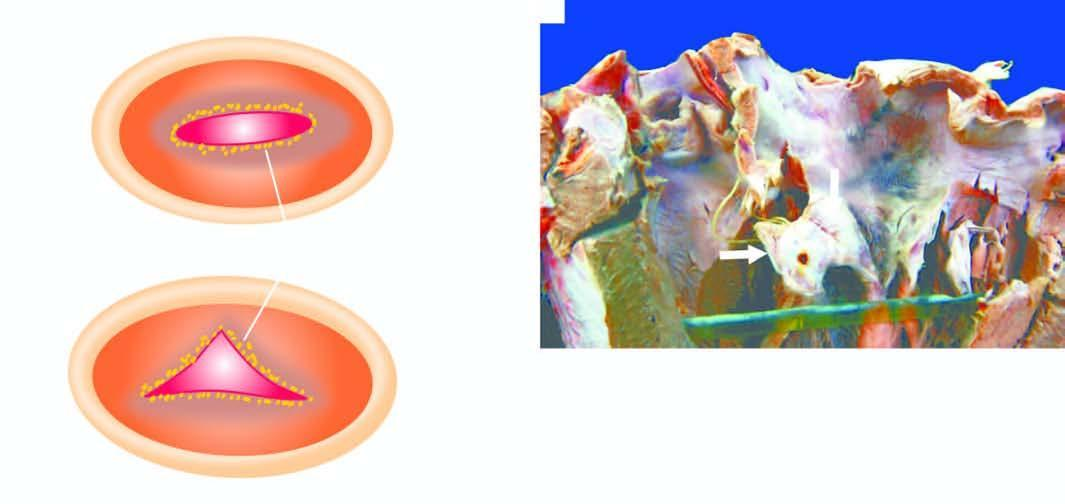what show irregularly scarred mitral valve leaving a fish-mouth or buttonhole opening between its two cusps?
Answer the question using a single word or phrase. Opened up chambers and valves of the left heart 